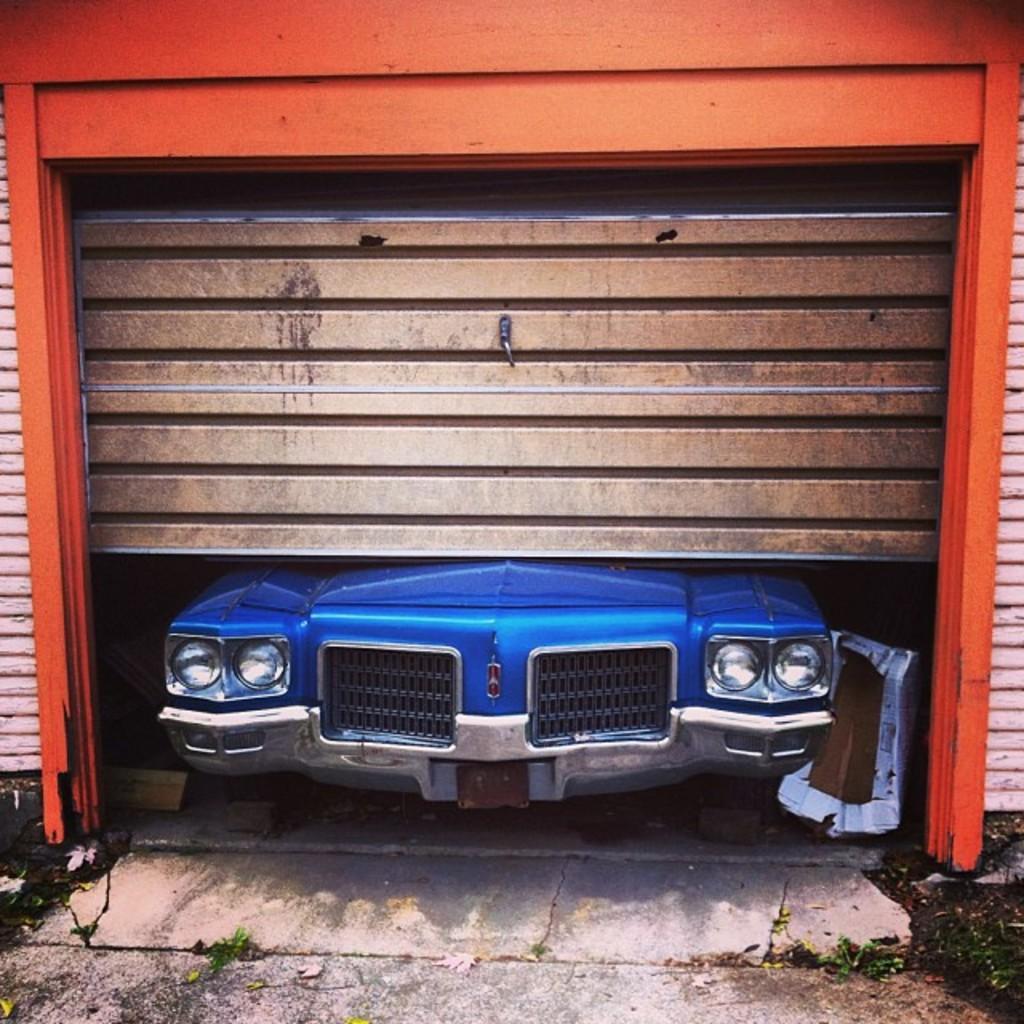In one or two sentences, can you explain what this image depicts? In the image we can see a house, in the house there is a vehicle. 